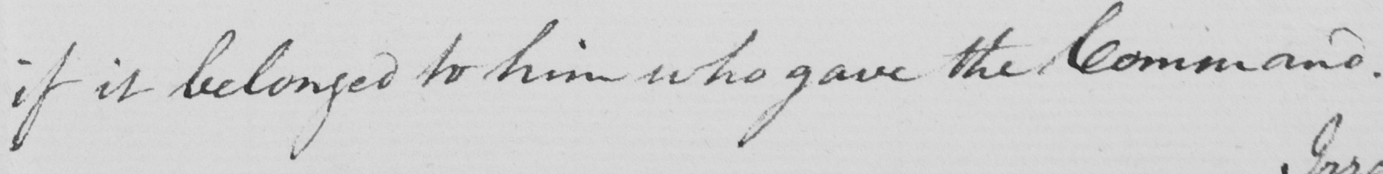Can you read and transcribe this handwriting? if it belonged to him who gave the Command . 